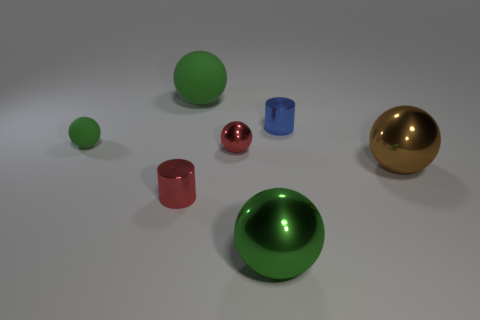How do the materials of the objects compare to each other? The objects showcase a variety of materials. The green and golden objects have matte surfaces that don't reflect much light, providing a soft appearance. In contrast, the red and pink objects have shiny, reflective surfaces that mirror their surroundings, indicative of a metallic or polished finish. The blue cup has a slightly reflective and glossy surface that seems somewhere in between the matte and the shiny finishes. 